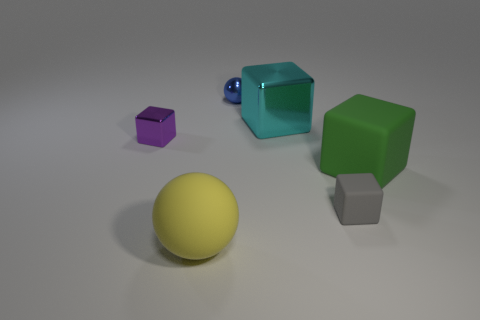Subtract all yellow blocks. Subtract all brown cylinders. How many blocks are left? 4 Add 3 cyan shiny things. How many objects exist? 9 Subtract all cubes. How many objects are left? 2 Subtract 0 green cylinders. How many objects are left? 6 Subtract all rubber blocks. Subtract all big cyan metal objects. How many objects are left? 3 Add 1 small rubber objects. How many small rubber objects are left? 2 Add 5 gray metallic cubes. How many gray metallic cubes exist? 5 